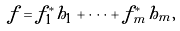Convert formula to latex. <formula><loc_0><loc_0><loc_500><loc_500>f = f _ { 1 } ^ { * } h _ { 1 } + \cdots + f _ { m } ^ { * } h _ { m } ,</formula> 